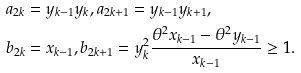<formula> <loc_0><loc_0><loc_500><loc_500>a _ { 2 k } & = y _ { k - 1 } y _ { k } , a _ { 2 k + 1 } = y _ { k - 1 } y _ { k + 1 } , \\ b _ { 2 k } & = x _ { k - 1 } , b _ { 2 k + 1 } = y _ { k } ^ { 2 } \frac { \theta ^ { 2 } x _ { k - 1 } - \theta ^ { 2 } y _ { k - 1 } } { x _ { k - 1 } } \geq 1 .</formula> 